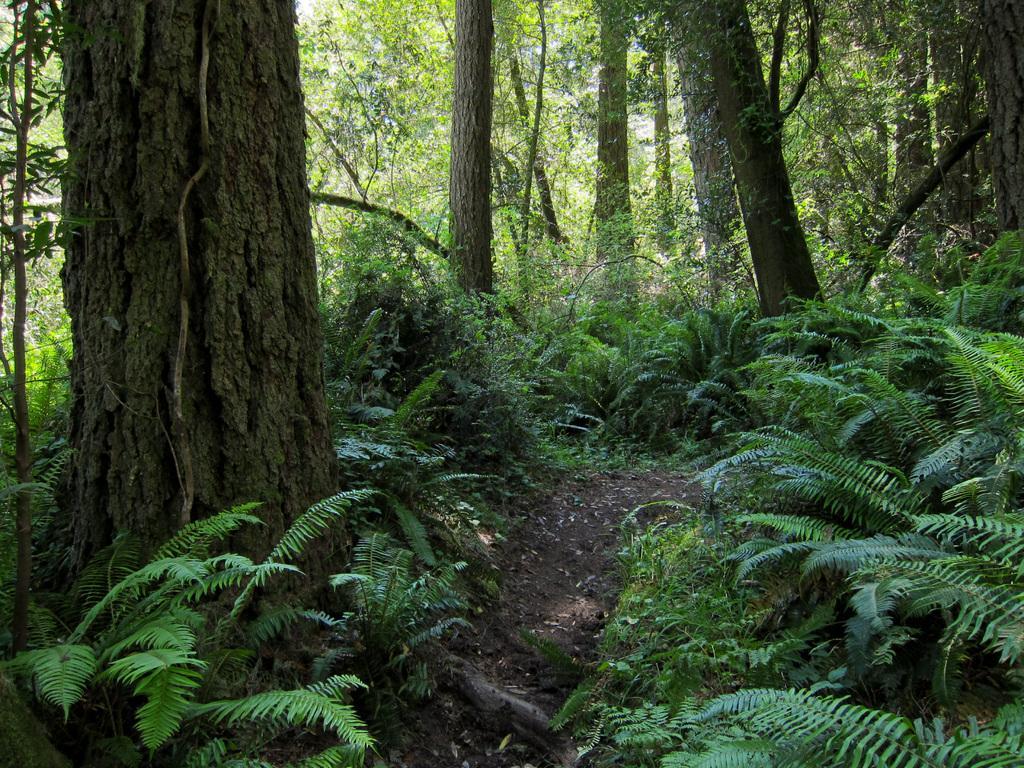Describe this image in one or two sentences. In this image we can see the plants and trees in the background. 